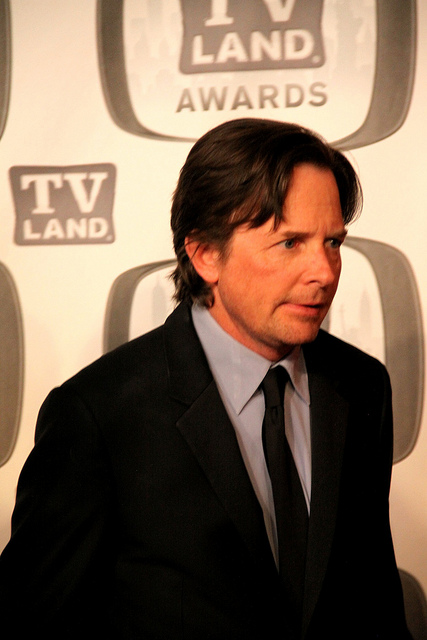Identify the text displayed in this image. TV LAND LAND. AWARDS TV 